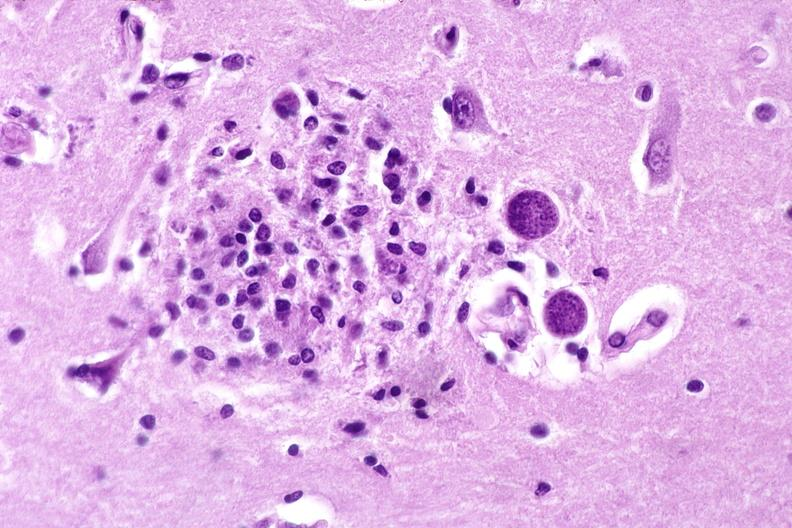does cyst show brain, toxoplasma encephalitis?
Answer the question using a single word or phrase. No 